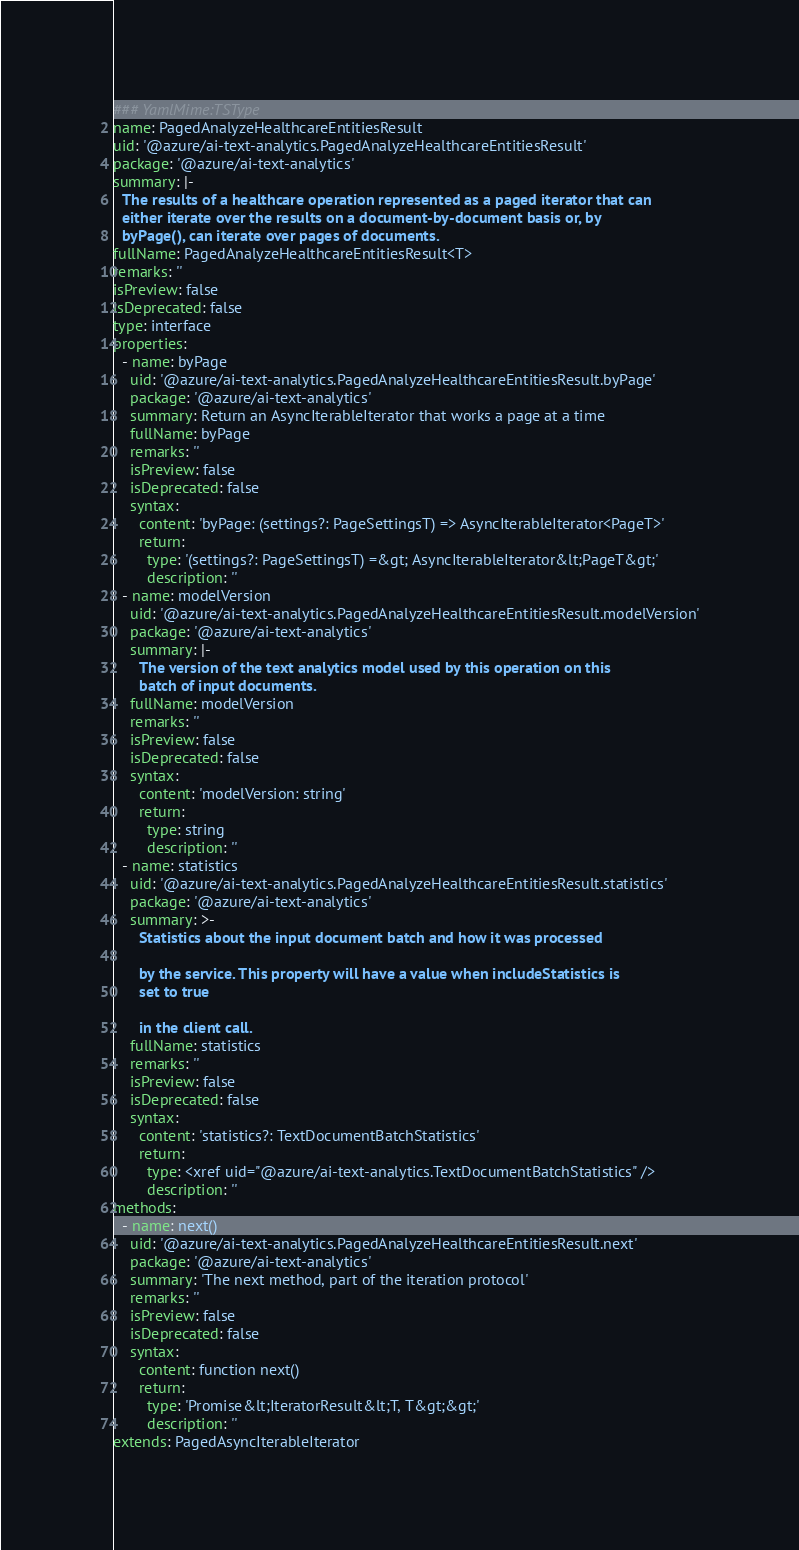Convert code to text. <code><loc_0><loc_0><loc_500><loc_500><_YAML_>### YamlMime:TSType
name: PagedAnalyzeHealthcareEntitiesResult
uid: '@azure/ai-text-analytics.PagedAnalyzeHealthcareEntitiesResult'
package: '@azure/ai-text-analytics'
summary: |-
  The results of a healthcare operation represented as a paged iterator that can
  either iterate over the results on a document-by-document basis or, by
  byPage(), can iterate over pages of documents.
fullName: PagedAnalyzeHealthcareEntitiesResult<T>
remarks: ''
isPreview: false
isDeprecated: false
type: interface
properties:
  - name: byPage
    uid: '@azure/ai-text-analytics.PagedAnalyzeHealthcareEntitiesResult.byPage'
    package: '@azure/ai-text-analytics'
    summary: Return an AsyncIterableIterator that works a page at a time
    fullName: byPage
    remarks: ''
    isPreview: false
    isDeprecated: false
    syntax:
      content: 'byPage: (settings?: PageSettingsT) => AsyncIterableIterator<PageT>'
      return:
        type: '(settings?: PageSettingsT) =&gt; AsyncIterableIterator&lt;PageT&gt;'
        description: ''
  - name: modelVersion
    uid: '@azure/ai-text-analytics.PagedAnalyzeHealthcareEntitiesResult.modelVersion'
    package: '@azure/ai-text-analytics'
    summary: |-
      The version of the text analytics model used by this operation on this
      batch of input documents.
    fullName: modelVersion
    remarks: ''
    isPreview: false
    isDeprecated: false
    syntax:
      content: 'modelVersion: string'
      return:
        type: string
        description: ''
  - name: statistics
    uid: '@azure/ai-text-analytics.PagedAnalyzeHealthcareEntitiesResult.statistics'
    package: '@azure/ai-text-analytics'
    summary: >-
      Statistics about the input document batch and how it was processed

      by the service. This property will have a value when includeStatistics is
      set to true

      in the client call.
    fullName: statistics
    remarks: ''
    isPreview: false
    isDeprecated: false
    syntax:
      content: 'statistics?: TextDocumentBatchStatistics'
      return:
        type: <xref uid="@azure/ai-text-analytics.TextDocumentBatchStatistics" />
        description: ''
methods:
  - name: next()
    uid: '@azure/ai-text-analytics.PagedAnalyzeHealthcareEntitiesResult.next'
    package: '@azure/ai-text-analytics'
    summary: 'The next method, part of the iteration protocol'
    remarks: ''
    isPreview: false
    isDeprecated: false
    syntax:
      content: function next()
      return:
        type: 'Promise&lt;IteratorResult&lt;T, T&gt;&gt;'
        description: ''
extends: PagedAsyncIterableIterator
</code> 